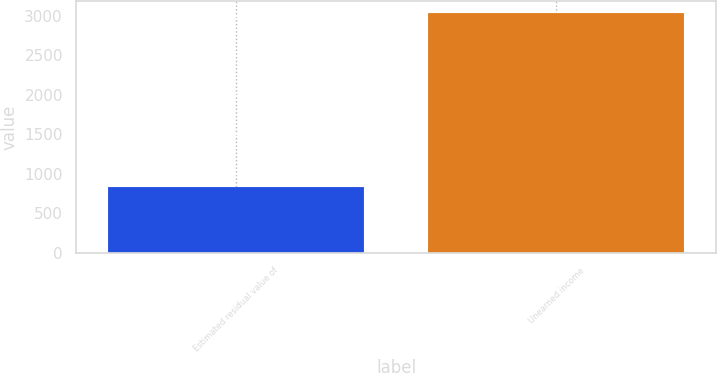<chart> <loc_0><loc_0><loc_500><loc_500><bar_chart><fcel>Estimated residual value of<fcel>Unearned income<nl><fcel>833<fcel>3032<nl></chart> 